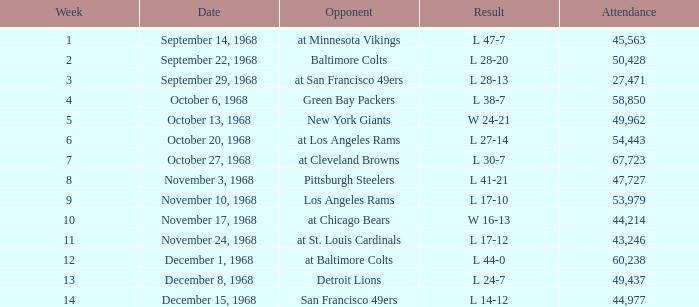Which Attendance has an Opponent of new york giants, and a Week smaller than 5? None. 